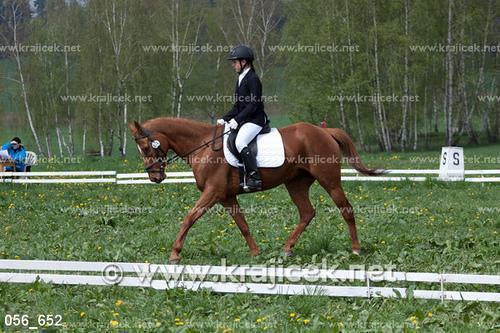How many horses?
Give a very brief answer. 1. How many rails in fence?
Give a very brief answer. 2. 